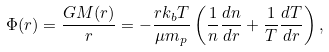<formula> <loc_0><loc_0><loc_500><loc_500>\Phi ( r ) = \frac { G M ( r ) } { r } = - \frac { r k _ { b } T } { \mu m _ { p } } \left ( \frac { 1 } { n } \frac { d n } { d r } + \frac { 1 } { T } \frac { d T } { d r } \right ) ,</formula> 